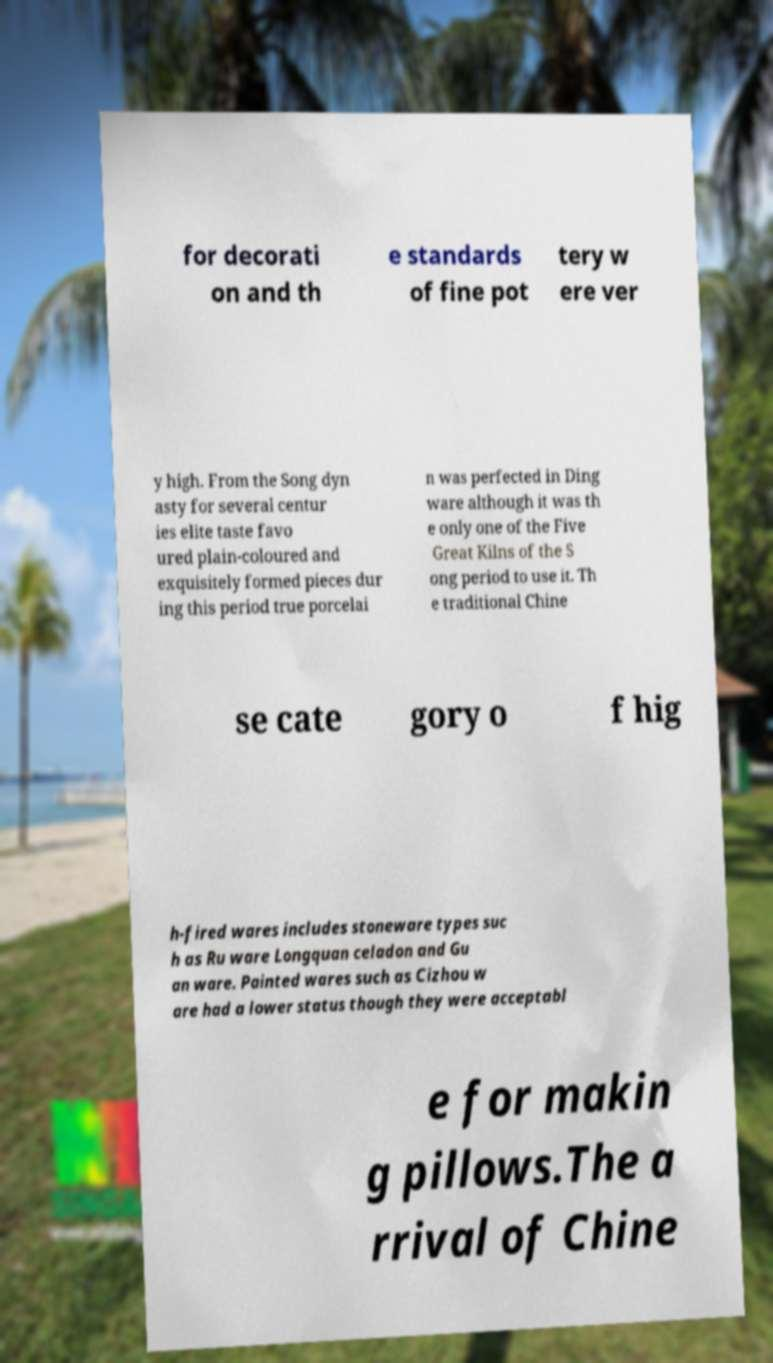Could you extract and type out the text from this image? for decorati on and th e standards of fine pot tery w ere ver y high. From the Song dyn asty for several centur ies elite taste favo ured plain-coloured and exquisitely formed pieces dur ing this period true porcelai n was perfected in Ding ware although it was th e only one of the Five Great Kilns of the S ong period to use it. Th e traditional Chine se cate gory o f hig h-fired wares includes stoneware types suc h as Ru ware Longquan celadon and Gu an ware. Painted wares such as Cizhou w are had a lower status though they were acceptabl e for makin g pillows.The a rrival of Chine 